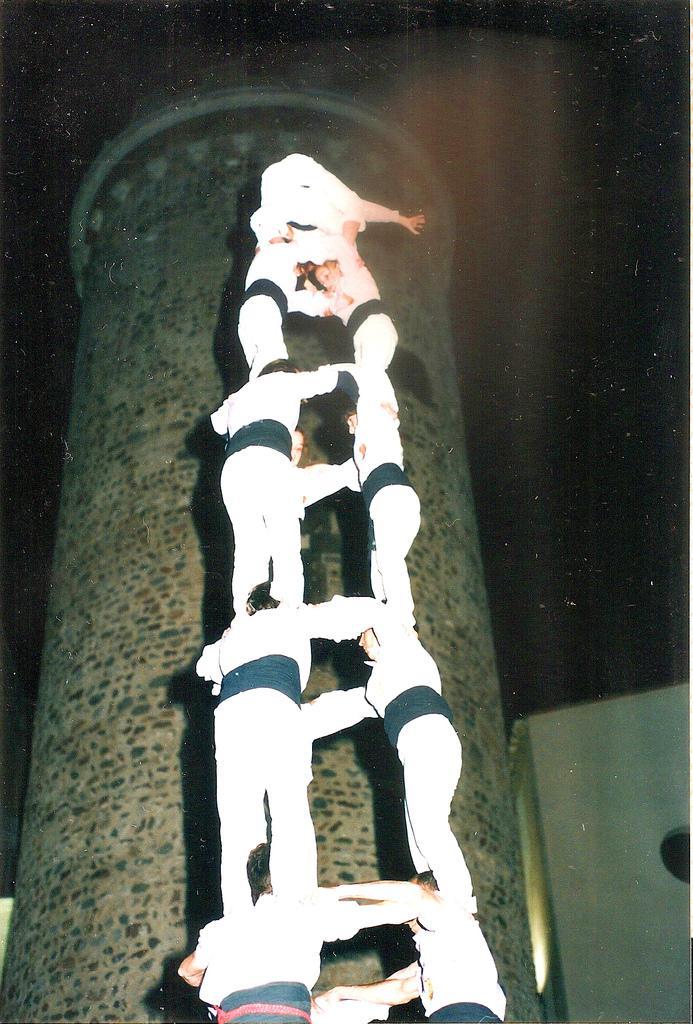How would you summarize this image in a sentence or two? In this image I can see a group of people standing one above the other. In the background, I can see the wall. 